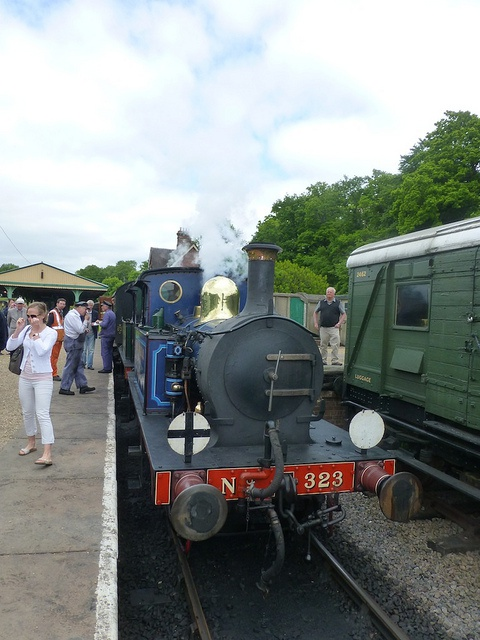Describe the objects in this image and their specific colors. I can see train in lightblue, black, gray, blue, and navy tones, train in lightblue, black, teal, and darkgreen tones, people in lightblue, lavender, darkgray, and lightgray tones, people in lightblue, gray, black, and darkgray tones, and people in lightblue, darkgray, black, and gray tones in this image. 